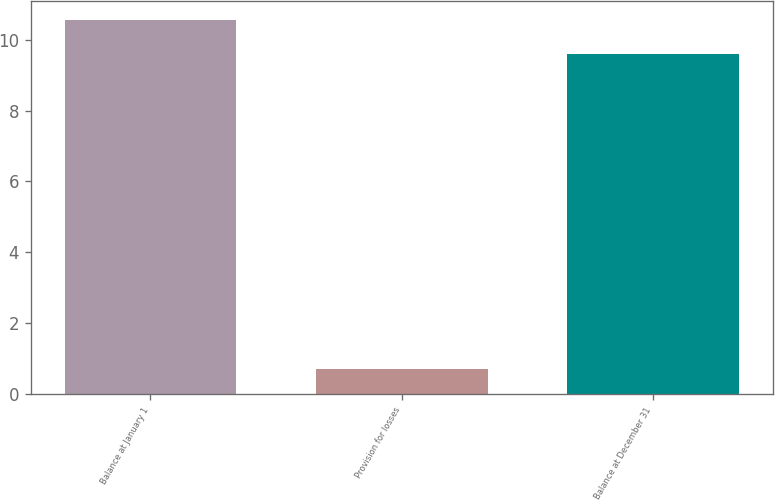Convert chart. <chart><loc_0><loc_0><loc_500><loc_500><bar_chart><fcel>Balance at January 1<fcel>Provision for losses<fcel>Balance at December 31<nl><fcel>10.56<fcel>0.7<fcel>9.6<nl></chart> 